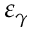<formula> <loc_0><loc_0><loc_500><loc_500>\varepsilon _ { \gamma }</formula> 